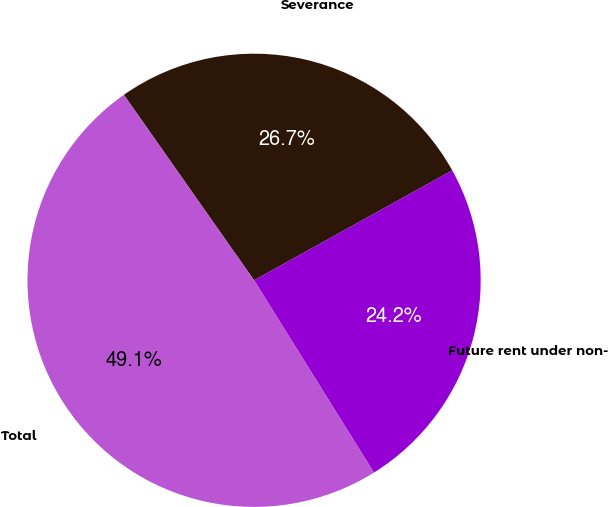Convert chart to OTSL. <chart><loc_0><loc_0><loc_500><loc_500><pie_chart><fcel>Severance<fcel>Future rent under non-<fcel>Total<nl><fcel>26.68%<fcel>24.19%<fcel>49.13%<nl></chart> 